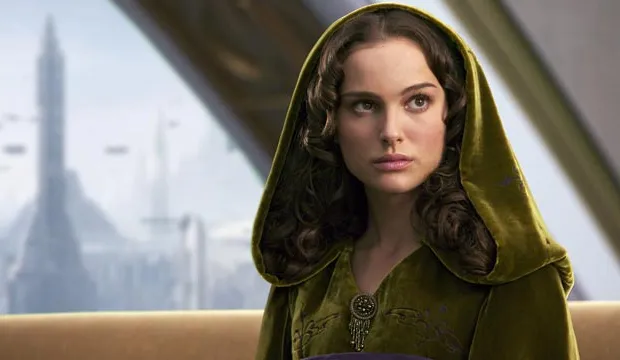What can you tell me about the significance of the cloak this character is wearing? The green velvet cloak adorned by the character is not only a costume choice that signifies nobility but also serves a symbolic purpose. In many narratives, particularly in fantasy and sci-fi genres, a cloak can represent secrecy or protection. Given the setting of a futuristic city and the character's thoughtful expression, the cloak might suggest her need to shield herself, physically or metaphorically, from surrounding political or social turmoil. 